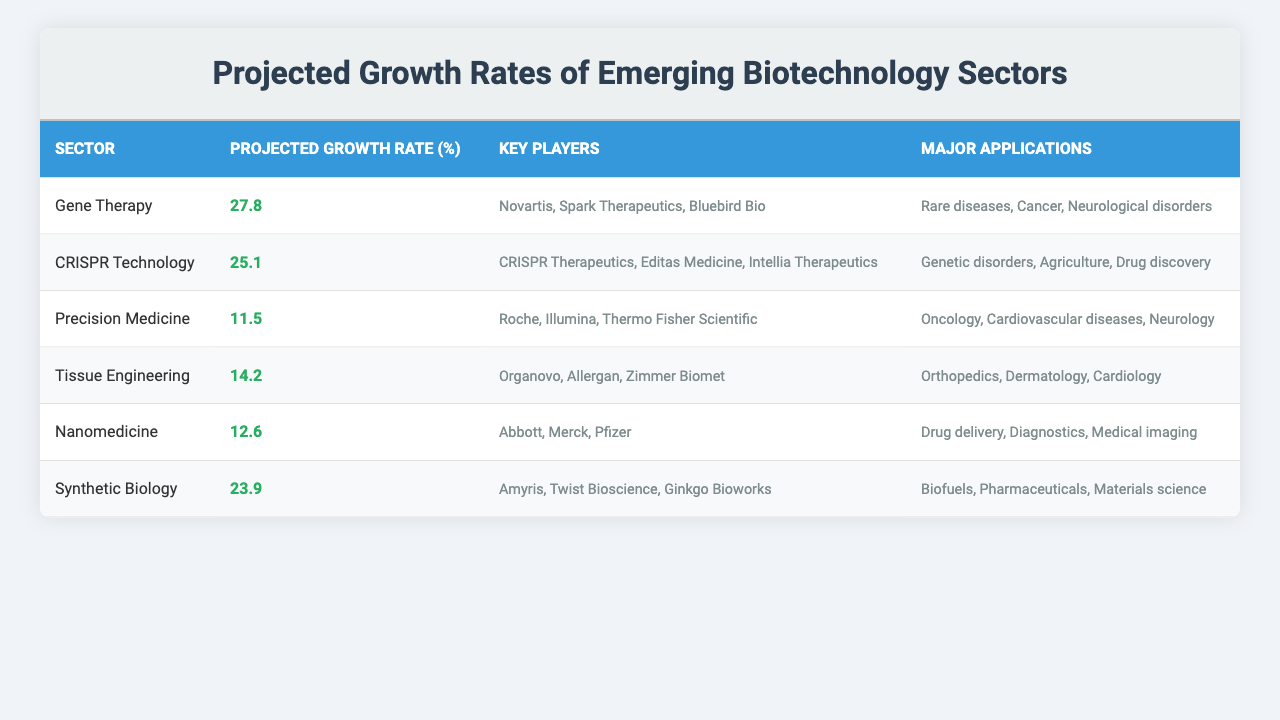What is the projected growth rate for Gene Therapy? The table shows that the projected growth rate for Gene Therapy is 27.8%.
Answer: 27.8% Which sector has the highest projected growth rate? The table indicates that Gene Therapy has the highest projected growth rate at 27.8%.
Answer: Gene Therapy What are the key players involved in CRISPR Technology? According to the table, the key players involved in CRISPR Technology are CRISPR Therapeutics, Editas Medicine, and Intellia Therapeutics.
Answer: CRISPR Therapeutics, Editas Medicine, Intellia Therapeutics Which sectors have a projected growth rate above 25%? By examining the table, the sectors with a projected growth rate above 25% are Gene Therapy (27.8%) and CRISPR Technology (25.1%).
Answer: Gene Therapy, CRISPR Technology What is the average projected growth rate of Precision Medicine, Tissue Engineering, and Nanomedicine? Precision Medicine has a growth rate of 11.5%, Tissue Engineering has 14.2%, and Nanomedicine has 12.6%. To find the average, sum these values: 11.5 + 14.2 + 12.6 = 38.3, then divide by 3. The average is 38.3 / 3 = 12.77.
Answer: 12.77 Is it true that Synthetic Biology has a projected growth rate lower than 20%? The table indicates that Synthetic Biology has a projected growth rate of 23.9%, which is greater than 20%. Therefore, the statement is false.
Answer: False What is the total projected growth rate of all the sectors listed? The sectors have the following growth rates: Gene Therapy (27.8%), CRISPR Technology (25.1%), Precision Medicine (11.5%), Tissue Engineering (14.2%), Nanomedicine (12.6%), and Synthetic Biology (23.9%). Summing these: 27.8 + 25.1 + 11.5 + 14.2 + 12.6 + 23.9 = 115.1%.
Answer: 115.1% Which sector focuses on drug delivery as a major application? The table identifies Nanomedicine as having drug delivery listed as a major application.
Answer: Nanomedicine What is the difference between the projected growth rates of CRISPR Technology and Synthetic Biology? The projected growth rate for CRISPR Technology is 25.1%, and for Synthetic Biology, it is 23.9%. The difference is calculated as 25.1 - 23.9 = 1.2%.
Answer: 1.2% Are all sectors listed addressing diseases in their major applications? Looking at the major applications, sectors such as Gene Therapy and Precision Medicine specifically address diseases. Therefore, it is true that most sectors relate to diseases, but not all applications focus solely on disease. This statement cannot be true for sectors like Synthetic Biology, which also includes non-disease related applications.
Answer: False 